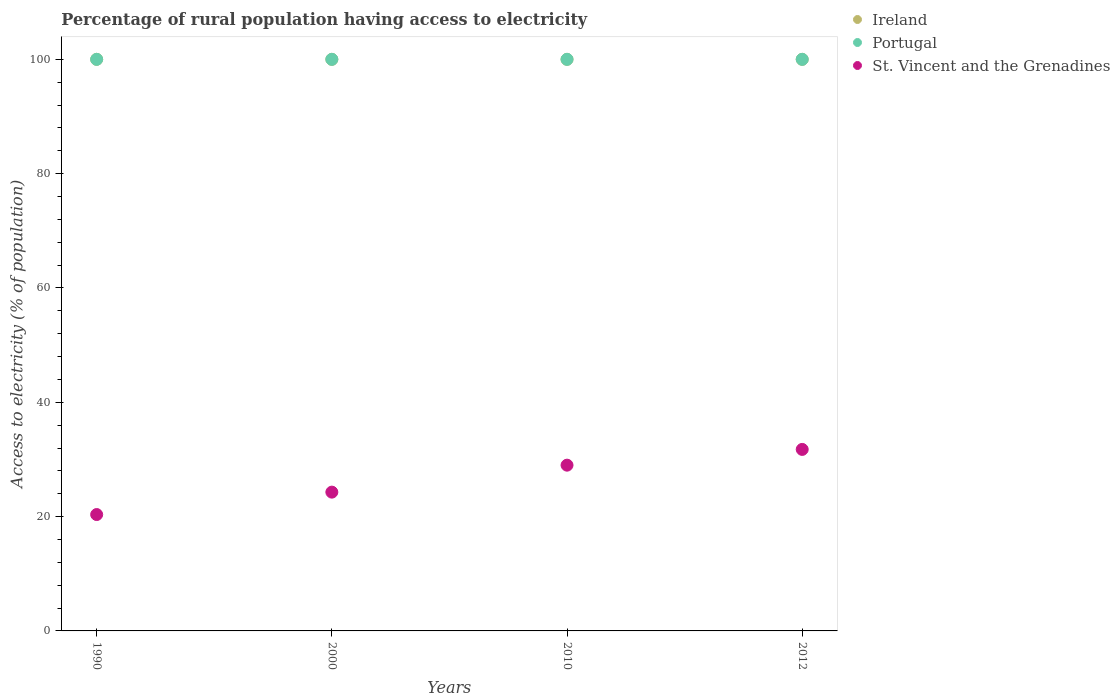Is the number of dotlines equal to the number of legend labels?
Ensure brevity in your answer.  Yes. What is the percentage of rural population having access to electricity in Portugal in 2010?
Provide a succinct answer. 100. Across all years, what is the maximum percentage of rural population having access to electricity in Ireland?
Your answer should be compact. 100. Across all years, what is the minimum percentage of rural population having access to electricity in St. Vincent and the Grenadines?
Your answer should be compact. 20.36. In which year was the percentage of rural population having access to electricity in Ireland maximum?
Offer a very short reply. 1990. In which year was the percentage of rural population having access to electricity in St. Vincent and the Grenadines minimum?
Give a very brief answer. 1990. What is the total percentage of rural population having access to electricity in Ireland in the graph?
Offer a terse response. 400. What is the difference between the percentage of rural population having access to electricity in Portugal in 1990 and that in 2000?
Provide a short and direct response. 0. What is the difference between the percentage of rural population having access to electricity in Ireland in 2000 and the percentage of rural population having access to electricity in Portugal in 2010?
Provide a short and direct response. 0. What is the average percentage of rural population having access to electricity in St. Vincent and the Grenadines per year?
Offer a terse response. 26.35. In the year 2000, what is the difference between the percentage of rural population having access to electricity in St. Vincent and the Grenadines and percentage of rural population having access to electricity in Portugal?
Your answer should be compact. -75.72. In how many years, is the percentage of rural population having access to electricity in Portugal greater than 76 %?
Offer a very short reply. 4. What is the ratio of the percentage of rural population having access to electricity in St. Vincent and the Grenadines in 2000 to that in 2010?
Ensure brevity in your answer.  0.84. Is the percentage of rural population having access to electricity in Ireland in 1990 less than that in 2012?
Your response must be concise. No. What is the difference between the highest and the second highest percentage of rural population having access to electricity in Portugal?
Offer a very short reply. 0. What is the difference between the highest and the lowest percentage of rural population having access to electricity in Portugal?
Offer a terse response. 0. Is it the case that in every year, the sum of the percentage of rural population having access to electricity in Portugal and percentage of rural population having access to electricity in St. Vincent and the Grenadines  is greater than the percentage of rural population having access to electricity in Ireland?
Make the answer very short. Yes. Does the percentage of rural population having access to electricity in St. Vincent and the Grenadines monotonically increase over the years?
Offer a terse response. Yes. Is the percentage of rural population having access to electricity in Ireland strictly greater than the percentage of rural population having access to electricity in Portugal over the years?
Keep it short and to the point. No. How many dotlines are there?
Offer a terse response. 3. How many years are there in the graph?
Keep it short and to the point. 4. What is the difference between two consecutive major ticks on the Y-axis?
Make the answer very short. 20. Are the values on the major ticks of Y-axis written in scientific E-notation?
Provide a succinct answer. No. Does the graph contain any zero values?
Keep it short and to the point. No. Does the graph contain grids?
Your answer should be compact. No. Where does the legend appear in the graph?
Your answer should be compact. Top right. What is the title of the graph?
Provide a short and direct response. Percentage of rural population having access to electricity. What is the label or title of the Y-axis?
Keep it short and to the point. Access to electricity (% of population). What is the Access to electricity (% of population) of Ireland in 1990?
Make the answer very short. 100. What is the Access to electricity (% of population) of St. Vincent and the Grenadines in 1990?
Your answer should be compact. 20.36. What is the Access to electricity (% of population) of St. Vincent and the Grenadines in 2000?
Provide a short and direct response. 24.28. What is the Access to electricity (% of population) in Ireland in 2010?
Give a very brief answer. 100. What is the Access to electricity (% of population) of Portugal in 2010?
Your response must be concise. 100. What is the Access to electricity (% of population) in St. Vincent and the Grenadines in 2010?
Give a very brief answer. 29. What is the Access to electricity (% of population) of Ireland in 2012?
Provide a succinct answer. 100. What is the Access to electricity (% of population) in St. Vincent and the Grenadines in 2012?
Provide a succinct answer. 31.75. Across all years, what is the maximum Access to electricity (% of population) of St. Vincent and the Grenadines?
Provide a succinct answer. 31.75. Across all years, what is the minimum Access to electricity (% of population) of St. Vincent and the Grenadines?
Make the answer very short. 20.36. What is the total Access to electricity (% of population) in Ireland in the graph?
Offer a very short reply. 400. What is the total Access to electricity (% of population) in Portugal in the graph?
Ensure brevity in your answer.  400. What is the total Access to electricity (% of population) in St. Vincent and the Grenadines in the graph?
Give a very brief answer. 105.4. What is the difference between the Access to electricity (% of population) in Ireland in 1990 and that in 2000?
Offer a very short reply. 0. What is the difference between the Access to electricity (% of population) of Portugal in 1990 and that in 2000?
Provide a succinct answer. 0. What is the difference between the Access to electricity (% of population) in St. Vincent and the Grenadines in 1990 and that in 2000?
Keep it short and to the point. -3.92. What is the difference between the Access to electricity (% of population) of St. Vincent and the Grenadines in 1990 and that in 2010?
Ensure brevity in your answer.  -8.64. What is the difference between the Access to electricity (% of population) of St. Vincent and the Grenadines in 1990 and that in 2012?
Provide a succinct answer. -11.39. What is the difference between the Access to electricity (% of population) in Ireland in 2000 and that in 2010?
Ensure brevity in your answer.  0. What is the difference between the Access to electricity (% of population) of Portugal in 2000 and that in 2010?
Your answer should be compact. 0. What is the difference between the Access to electricity (% of population) in St. Vincent and the Grenadines in 2000 and that in 2010?
Offer a very short reply. -4.72. What is the difference between the Access to electricity (% of population) of Ireland in 2000 and that in 2012?
Offer a terse response. 0. What is the difference between the Access to electricity (% of population) of St. Vincent and the Grenadines in 2000 and that in 2012?
Give a very brief answer. -7.47. What is the difference between the Access to electricity (% of population) of Portugal in 2010 and that in 2012?
Offer a very short reply. 0. What is the difference between the Access to electricity (% of population) in St. Vincent and the Grenadines in 2010 and that in 2012?
Make the answer very short. -2.75. What is the difference between the Access to electricity (% of population) of Ireland in 1990 and the Access to electricity (% of population) of St. Vincent and the Grenadines in 2000?
Ensure brevity in your answer.  75.72. What is the difference between the Access to electricity (% of population) of Portugal in 1990 and the Access to electricity (% of population) of St. Vincent and the Grenadines in 2000?
Give a very brief answer. 75.72. What is the difference between the Access to electricity (% of population) in Ireland in 1990 and the Access to electricity (% of population) in Portugal in 2010?
Keep it short and to the point. 0. What is the difference between the Access to electricity (% of population) of Ireland in 1990 and the Access to electricity (% of population) of St. Vincent and the Grenadines in 2010?
Give a very brief answer. 71. What is the difference between the Access to electricity (% of population) in Ireland in 1990 and the Access to electricity (% of population) in St. Vincent and the Grenadines in 2012?
Ensure brevity in your answer.  68.25. What is the difference between the Access to electricity (% of population) in Portugal in 1990 and the Access to electricity (% of population) in St. Vincent and the Grenadines in 2012?
Make the answer very short. 68.25. What is the difference between the Access to electricity (% of population) in Ireland in 2000 and the Access to electricity (% of population) in Portugal in 2010?
Give a very brief answer. 0. What is the difference between the Access to electricity (% of population) of Ireland in 2000 and the Access to electricity (% of population) of St. Vincent and the Grenadines in 2010?
Provide a succinct answer. 71. What is the difference between the Access to electricity (% of population) of Ireland in 2000 and the Access to electricity (% of population) of St. Vincent and the Grenadines in 2012?
Ensure brevity in your answer.  68.25. What is the difference between the Access to electricity (% of population) in Portugal in 2000 and the Access to electricity (% of population) in St. Vincent and the Grenadines in 2012?
Offer a terse response. 68.25. What is the difference between the Access to electricity (% of population) of Ireland in 2010 and the Access to electricity (% of population) of Portugal in 2012?
Your answer should be very brief. 0. What is the difference between the Access to electricity (% of population) of Ireland in 2010 and the Access to electricity (% of population) of St. Vincent and the Grenadines in 2012?
Give a very brief answer. 68.25. What is the difference between the Access to electricity (% of population) in Portugal in 2010 and the Access to electricity (% of population) in St. Vincent and the Grenadines in 2012?
Offer a very short reply. 68.25. What is the average Access to electricity (% of population) of St. Vincent and the Grenadines per year?
Your response must be concise. 26.35. In the year 1990, what is the difference between the Access to electricity (% of population) in Ireland and Access to electricity (% of population) in Portugal?
Keep it short and to the point. 0. In the year 1990, what is the difference between the Access to electricity (% of population) of Ireland and Access to electricity (% of population) of St. Vincent and the Grenadines?
Make the answer very short. 79.64. In the year 1990, what is the difference between the Access to electricity (% of population) in Portugal and Access to electricity (% of population) in St. Vincent and the Grenadines?
Make the answer very short. 79.64. In the year 2000, what is the difference between the Access to electricity (% of population) of Ireland and Access to electricity (% of population) of St. Vincent and the Grenadines?
Keep it short and to the point. 75.72. In the year 2000, what is the difference between the Access to electricity (% of population) in Portugal and Access to electricity (% of population) in St. Vincent and the Grenadines?
Provide a succinct answer. 75.72. In the year 2010, what is the difference between the Access to electricity (% of population) of Portugal and Access to electricity (% of population) of St. Vincent and the Grenadines?
Give a very brief answer. 71. In the year 2012, what is the difference between the Access to electricity (% of population) of Ireland and Access to electricity (% of population) of St. Vincent and the Grenadines?
Your response must be concise. 68.25. In the year 2012, what is the difference between the Access to electricity (% of population) of Portugal and Access to electricity (% of population) of St. Vincent and the Grenadines?
Offer a terse response. 68.25. What is the ratio of the Access to electricity (% of population) in Portugal in 1990 to that in 2000?
Your response must be concise. 1. What is the ratio of the Access to electricity (% of population) in St. Vincent and the Grenadines in 1990 to that in 2000?
Ensure brevity in your answer.  0.84. What is the ratio of the Access to electricity (% of population) in Ireland in 1990 to that in 2010?
Ensure brevity in your answer.  1. What is the ratio of the Access to electricity (% of population) in St. Vincent and the Grenadines in 1990 to that in 2010?
Ensure brevity in your answer.  0.7. What is the ratio of the Access to electricity (% of population) in Ireland in 1990 to that in 2012?
Your response must be concise. 1. What is the ratio of the Access to electricity (% of population) in Portugal in 1990 to that in 2012?
Make the answer very short. 1. What is the ratio of the Access to electricity (% of population) of St. Vincent and the Grenadines in 1990 to that in 2012?
Provide a short and direct response. 0.64. What is the ratio of the Access to electricity (% of population) in Portugal in 2000 to that in 2010?
Provide a succinct answer. 1. What is the ratio of the Access to electricity (% of population) of St. Vincent and the Grenadines in 2000 to that in 2010?
Keep it short and to the point. 0.84. What is the ratio of the Access to electricity (% of population) in Ireland in 2000 to that in 2012?
Your answer should be compact. 1. What is the ratio of the Access to electricity (% of population) in St. Vincent and the Grenadines in 2000 to that in 2012?
Ensure brevity in your answer.  0.76. What is the ratio of the Access to electricity (% of population) of Portugal in 2010 to that in 2012?
Offer a very short reply. 1. What is the ratio of the Access to electricity (% of population) in St. Vincent and the Grenadines in 2010 to that in 2012?
Your response must be concise. 0.91. What is the difference between the highest and the second highest Access to electricity (% of population) of Ireland?
Keep it short and to the point. 0. What is the difference between the highest and the second highest Access to electricity (% of population) in Portugal?
Provide a succinct answer. 0. What is the difference between the highest and the second highest Access to electricity (% of population) of St. Vincent and the Grenadines?
Your response must be concise. 2.75. What is the difference between the highest and the lowest Access to electricity (% of population) in Ireland?
Make the answer very short. 0. What is the difference between the highest and the lowest Access to electricity (% of population) of Portugal?
Your answer should be very brief. 0. What is the difference between the highest and the lowest Access to electricity (% of population) in St. Vincent and the Grenadines?
Provide a short and direct response. 11.39. 